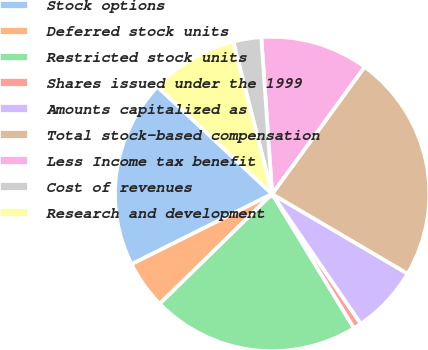Convert chart to OTSL. <chart><loc_0><loc_0><loc_500><loc_500><pie_chart><fcel>Stock options<fcel>Deferred stock units<fcel>Restricted stock units<fcel>Shares issued under the 1999<fcel>Amounts capitalized as<fcel>Total stock-based compensation<fcel>Less Income tax benefit<fcel>Cost of revenues<fcel>Research and development<nl><fcel>19.34%<fcel>4.94%<fcel>21.4%<fcel>0.82%<fcel>7.0%<fcel>23.46%<fcel>11.11%<fcel>2.88%<fcel>9.05%<nl></chart> 